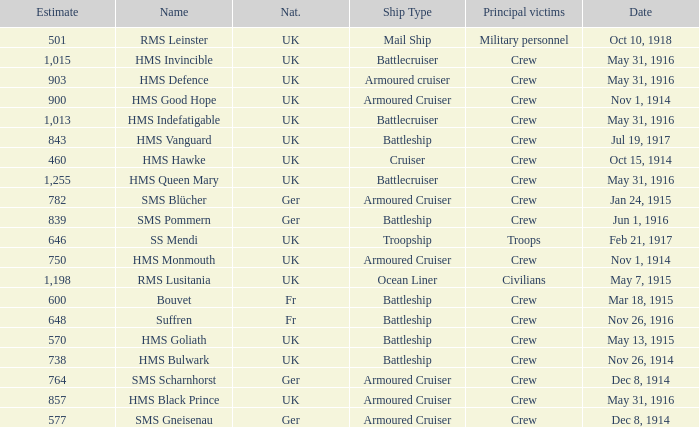What is the name of the battleship with the battle listed on may 13, 1915? HMS Goliath. 